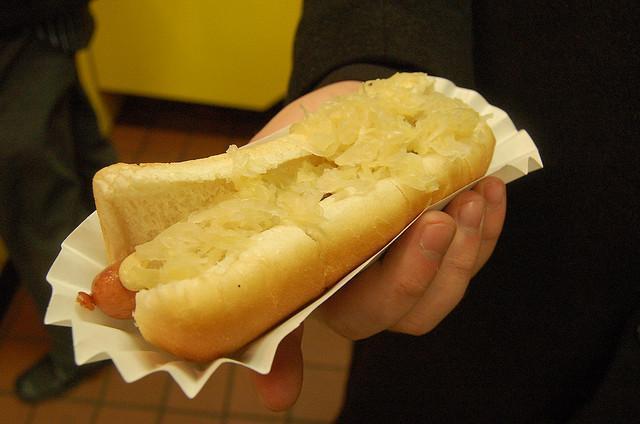How many people are there?
Give a very brief answer. 2. 